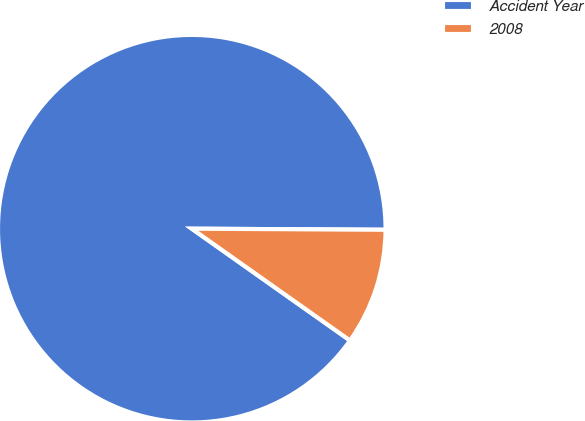Convert chart. <chart><loc_0><loc_0><loc_500><loc_500><pie_chart><fcel>Accident Year<fcel>2008<nl><fcel>90.3%<fcel>9.7%<nl></chart> 